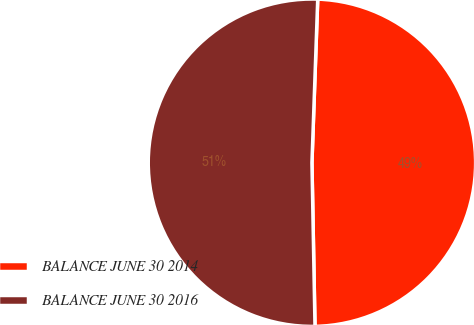Convert chart to OTSL. <chart><loc_0><loc_0><loc_500><loc_500><pie_chart><fcel>BALANCE JUNE 30 2014<fcel>BALANCE JUNE 30 2016<nl><fcel>49.14%<fcel>50.86%<nl></chart> 